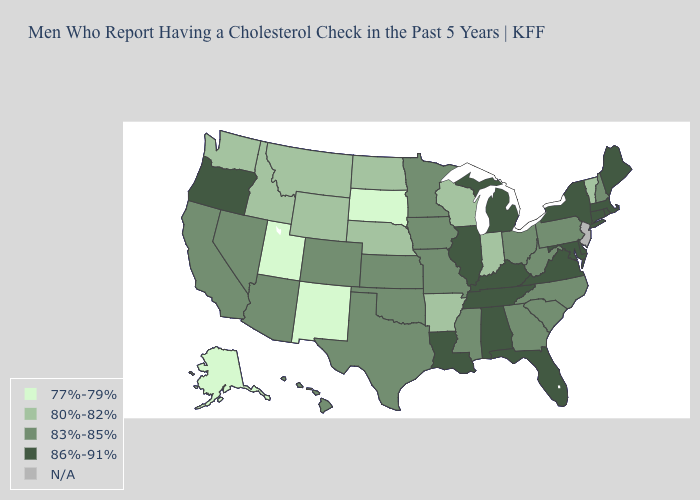Name the states that have a value in the range 86%-91%?
Short answer required. Alabama, Connecticut, Delaware, Florida, Illinois, Kentucky, Louisiana, Maine, Maryland, Massachusetts, Michigan, New York, Oregon, Rhode Island, Tennessee, Virginia. Among the states that border Ohio , does Michigan have the highest value?
Give a very brief answer. Yes. What is the highest value in states that border Connecticut?
Concise answer only. 86%-91%. Does Alaska have the lowest value in the West?
Give a very brief answer. Yes. Does the first symbol in the legend represent the smallest category?
Concise answer only. Yes. What is the value of Nebraska?
Answer briefly. 80%-82%. Which states have the highest value in the USA?
Quick response, please. Alabama, Connecticut, Delaware, Florida, Illinois, Kentucky, Louisiana, Maine, Maryland, Massachusetts, Michigan, New York, Oregon, Rhode Island, Tennessee, Virginia. Which states have the lowest value in the Northeast?
Write a very short answer. Vermont. What is the value of Minnesota?
Keep it brief. 83%-85%. Does South Dakota have the lowest value in the USA?
Keep it brief. Yes. Name the states that have a value in the range 80%-82%?
Give a very brief answer. Arkansas, Idaho, Indiana, Montana, Nebraska, North Dakota, Vermont, Washington, Wisconsin, Wyoming. Name the states that have a value in the range 83%-85%?
Write a very short answer. Arizona, California, Colorado, Georgia, Hawaii, Iowa, Kansas, Minnesota, Mississippi, Missouri, Nevada, New Hampshire, North Carolina, Ohio, Oklahoma, Pennsylvania, South Carolina, Texas, West Virginia. What is the value of Illinois?
Give a very brief answer. 86%-91%. 